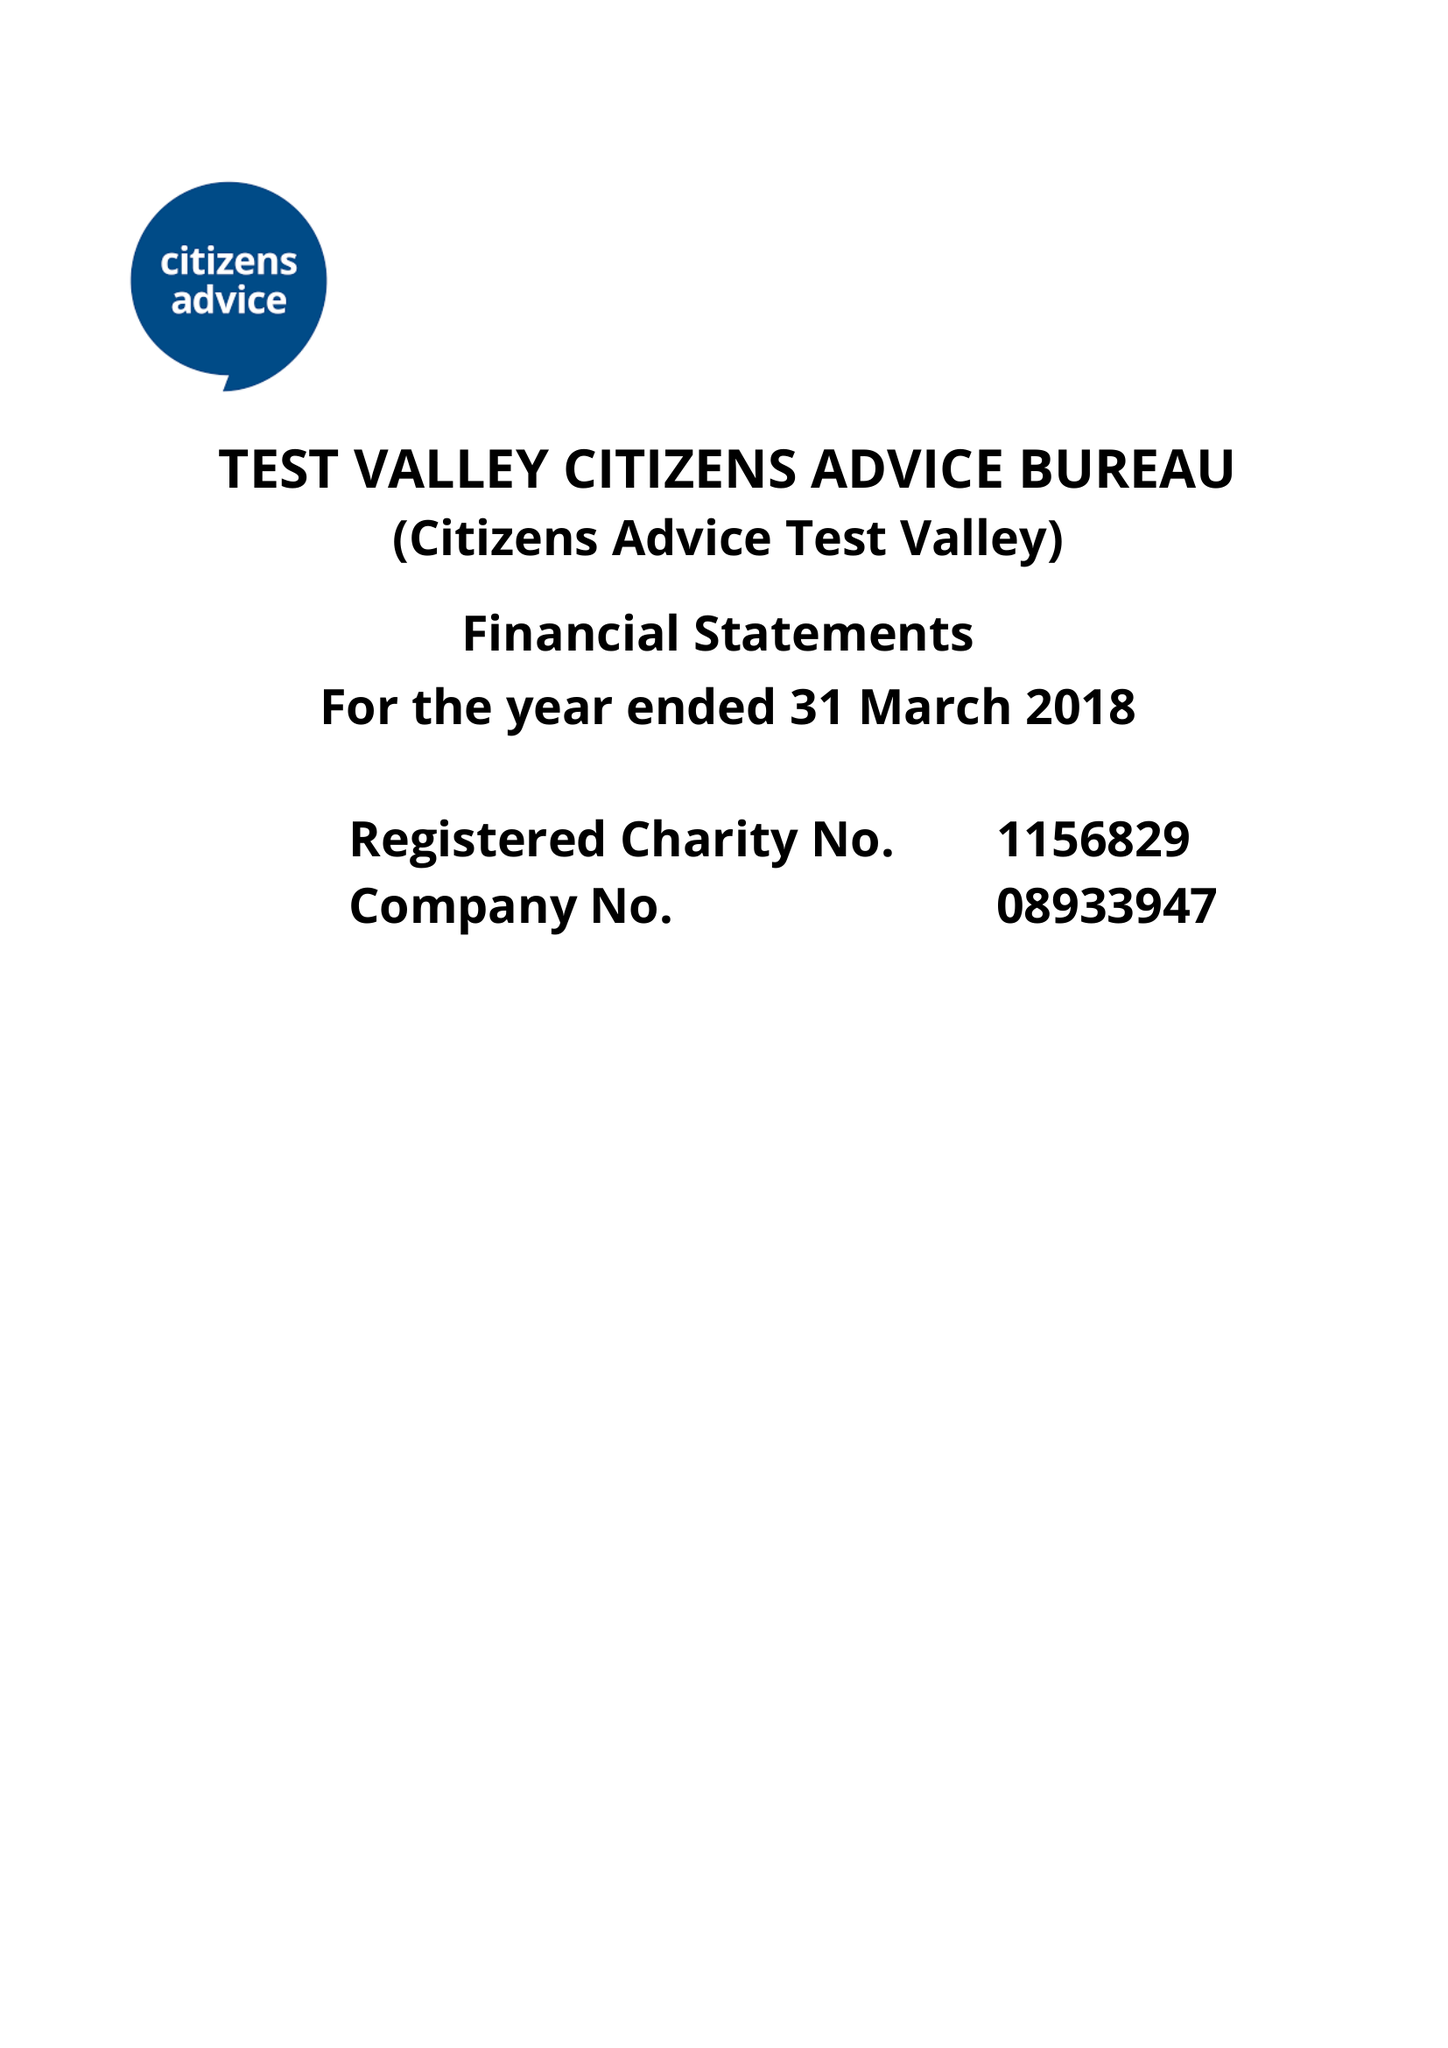What is the value for the spending_annually_in_british_pounds?
Answer the question using a single word or phrase. 296737.00 